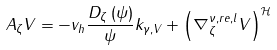Convert formula to latex. <formula><loc_0><loc_0><loc_500><loc_500>A _ { \zeta } V = - v _ { h } \frac { D _ { \zeta } \left ( \psi \right ) } { \psi } k _ { \gamma , V } + \left ( \nabla _ { \zeta } ^ { \nu , r e , l } V \right ) ^ { \mathcal { H } }</formula> 